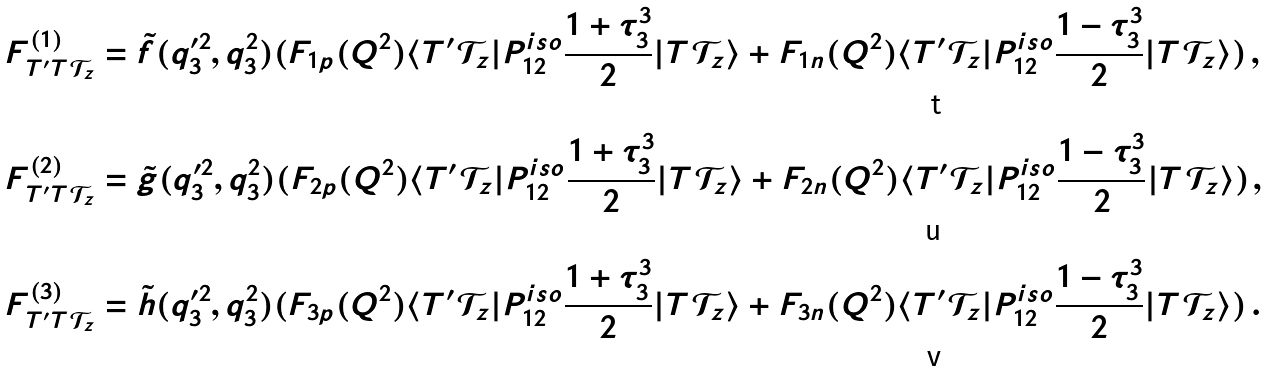<formula> <loc_0><loc_0><loc_500><loc_500>F ^ { ( 1 ) } _ { T ^ { \prime } T \mathcal { T } _ { z } } & = \tilde { f } ( q _ { 3 } ^ { \prime 2 } , q _ { 3 } ^ { 2 } ) ( F _ { 1 p } ( Q ^ { 2 } ) \langle T ^ { \prime } { \mathcal { T } } _ { z } | P ^ { i s o } _ { 1 2 } \frac { 1 + \tau ^ { 3 } _ { 3 } } { 2 } | T { \mathcal { T } } _ { z } \rangle + F _ { 1 n } ( Q ^ { 2 } ) \langle T ^ { \prime } { \mathcal { T } } _ { z } | P ^ { i s o } _ { 1 2 } \frac { 1 - \tau ^ { 3 } _ { 3 } } { 2 } | T { \mathcal { T } } _ { z } \rangle ) \, , \\ F ^ { ( 2 ) } _ { T ^ { \prime } T \mathcal { T } _ { z } } & = \tilde { g } ( q _ { 3 } ^ { \prime 2 } , q _ { 3 } ^ { 2 } ) ( F _ { 2 p } ( Q ^ { 2 } ) \langle T ^ { \prime } { \mathcal { T } } _ { z } | P ^ { i s o } _ { 1 2 } \frac { 1 + \tau ^ { 3 } _ { 3 } } { 2 } | T { \mathcal { T } } _ { z } \rangle + F _ { 2 n } ( Q ^ { 2 } ) \langle T ^ { \prime } { \mathcal { T } } _ { z } | P ^ { i s o } _ { 1 2 } \frac { 1 - \tau ^ { 3 } _ { 3 } } { 2 } | T { \mathcal { T } } _ { z } \rangle ) \, , \\ F ^ { ( 3 ) } _ { T ^ { \prime } T \mathcal { T } _ { z } } & = \tilde { h } ( q _ { 3 } ^ { \prime 2 } , q _ { 3 } ^ { 2 } ) ( F _ { 3 p } ( Q ^ { 2 } ) \langle T ^ { \prime } { \mathcal { T } } _ { z } | P ^ { i s o } _ { 1 2 } \frac { 1 + \tau ^ { 3 } _ { 3 } } { 2 } | T { \mathcal { T } } _ { z } \rangle + F _ { 3 n } ( Q ^ { 2 } ) \langle T ^ { \prime } { \mathcal { T } } _ { z } | P ^ { i s o } _ { 1 2 } \frac { 1 - \tau ^ { 3 } _ { 3 } } { 2 } | T { \mathcal { T } } _ { z } \rangle ) \, .</formula> 